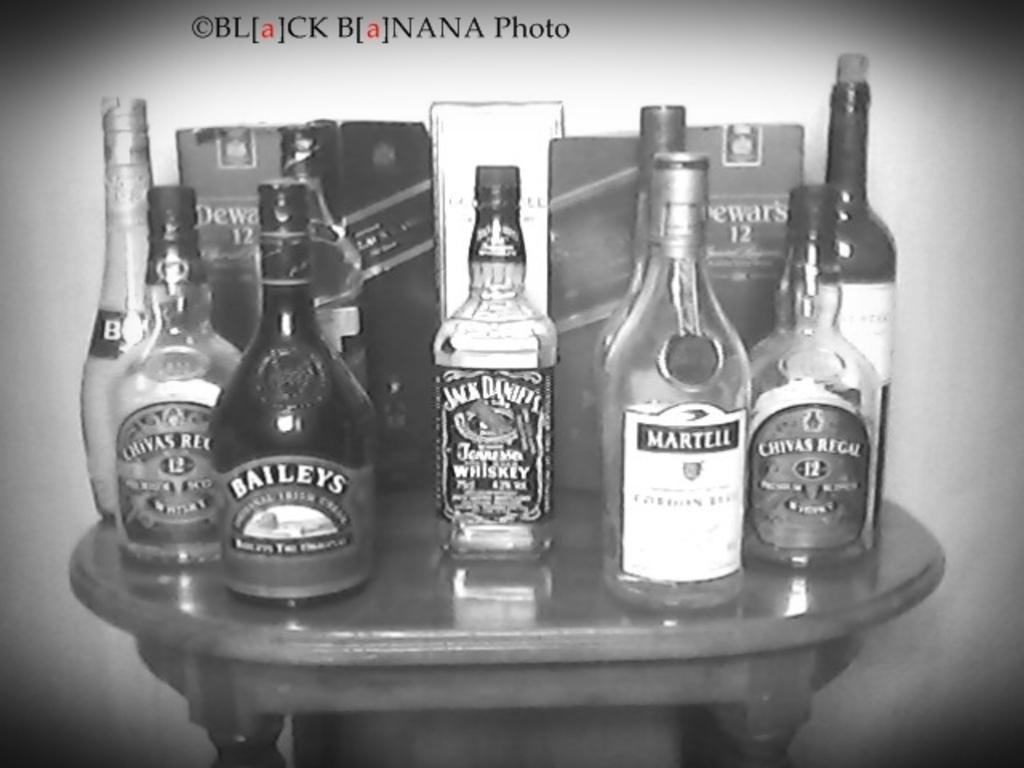What is the color scheme of the image? The image is black and white. What objects can be seen in the image? There are multiple bottles in the image. Where are the bottles located? The bottles are placed on a table. What type of secretary is sitting next to the bottles in the image? There is no secretary present in the image; it only features multiple bottles placed on a table. 